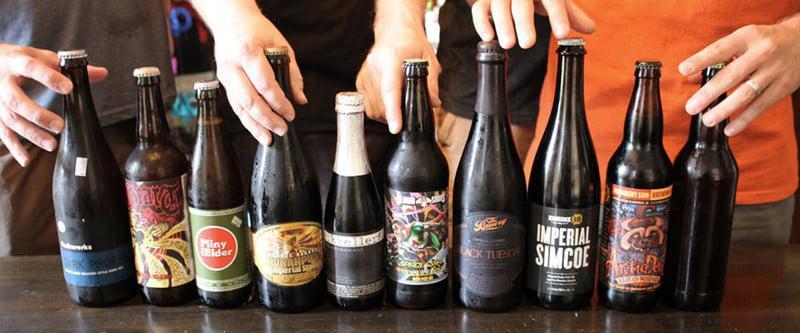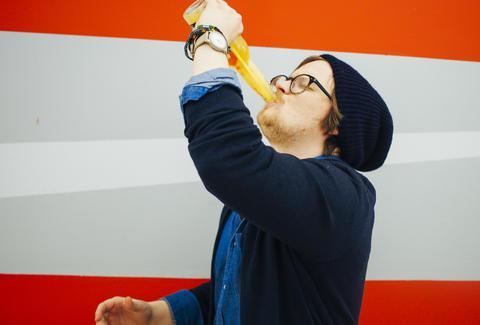The first image is the image on the left, the second image is the image on the right. Examine the images to the left and right. Is the description "In the right image, one person is lifting a glass bottle to drink, with their head tilted back." accurate? Answer yes or no. Yes. 